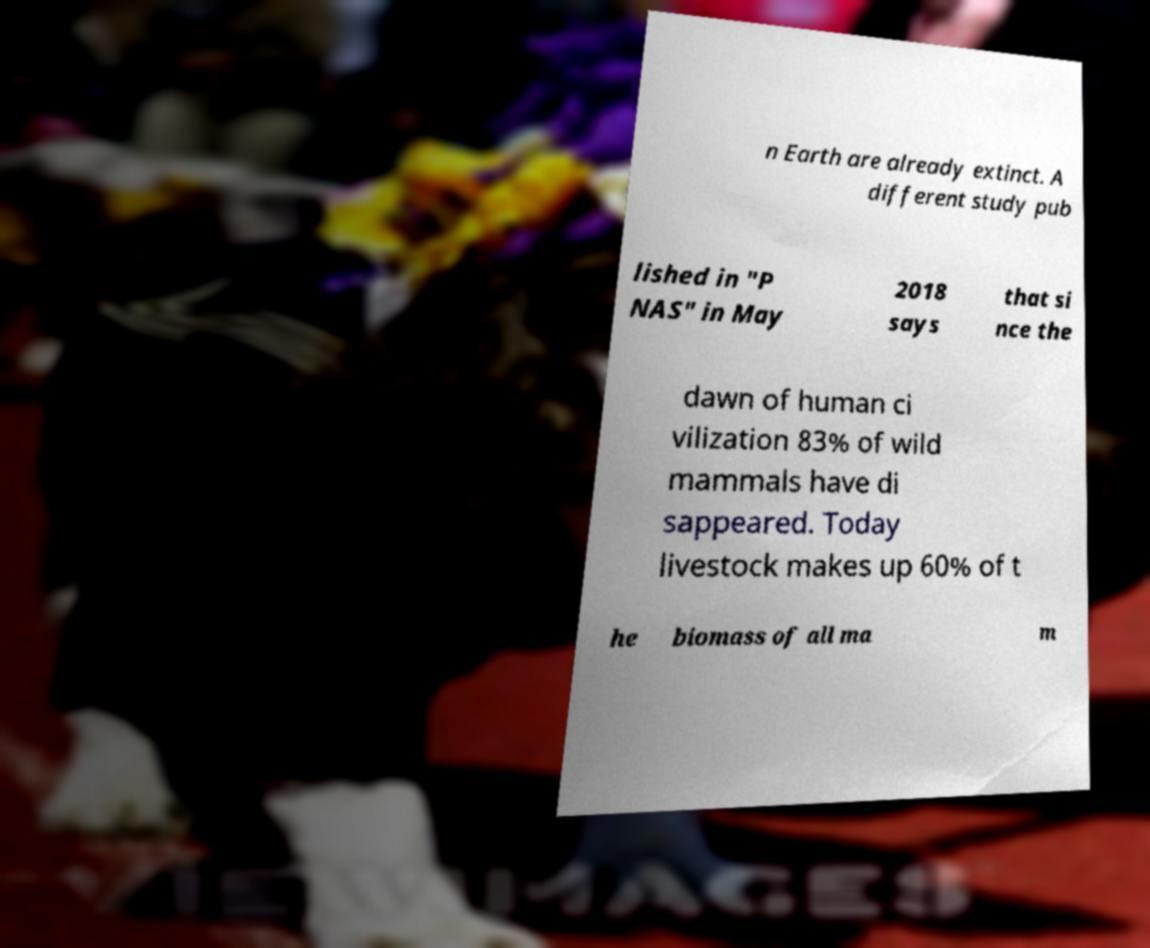For documentation purposes, I need the text within this image transcribed. Could you provide that? n Earth are already extinct. A different study pub lished in "P NAS" in May 2018 says that si nce the dawn of human ci vilization 83% of wild mammals have di sappeared. Today livestock makes up 60% of t he biomass of all ma m 